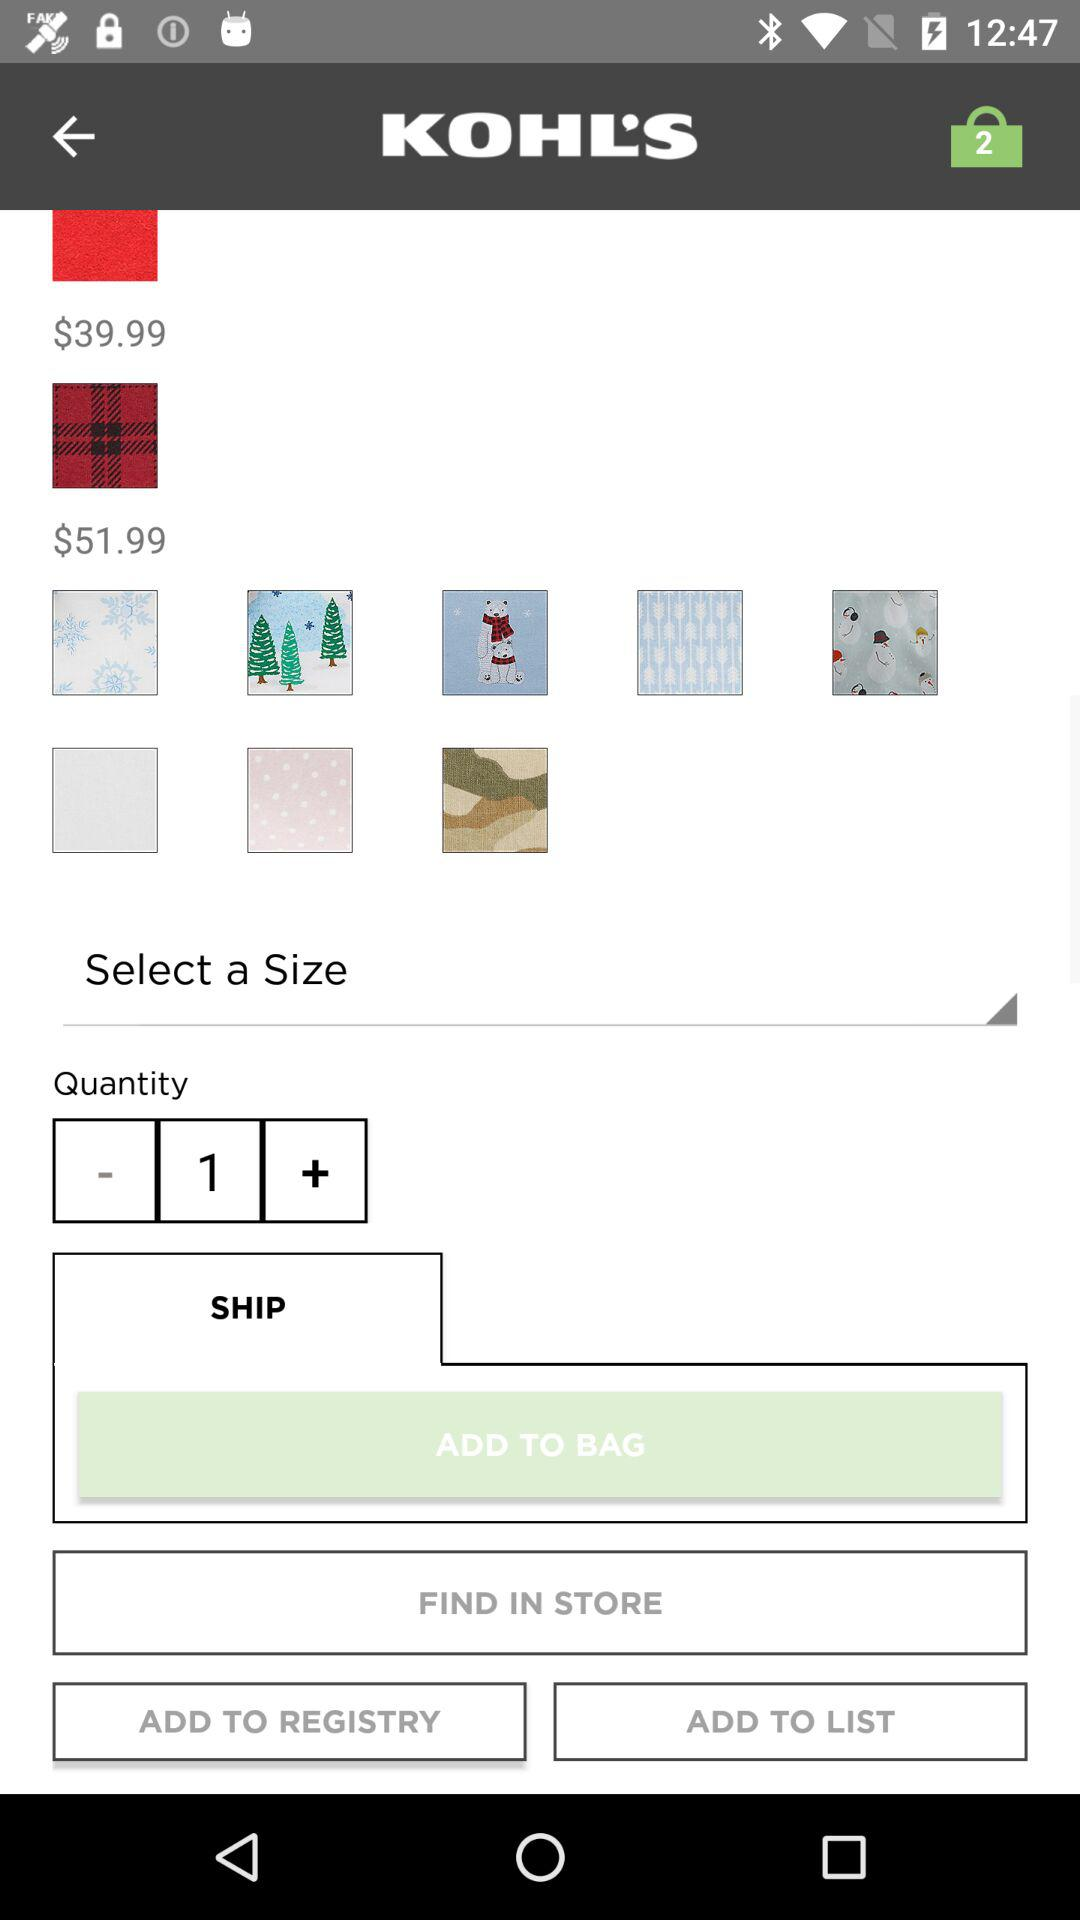What's the current quantity? The current quantity is 1. 